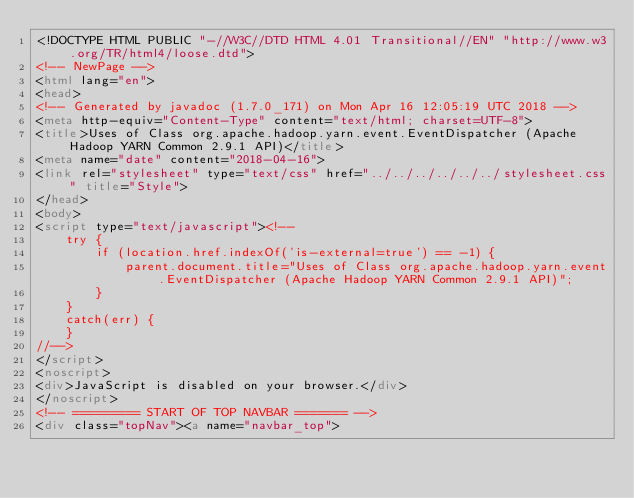Convert code to text. <code><loc_0><loc_0><loc_500><loc_500><_HTML_><!DOCTYPE HTML PUBLIC "-//W3C//DTD HTML 4.01 Transitional//EN" "http://www.w3.org/TR/html4/loose.dtd">
<!-- NewPage -->
<html lang="en">
<head>
<!-- Generated by javadoc (1.7.0_171) on Mon Apr 16 12:05:19 UTC 2018 -->
<meta http-equiv="Content-Type" content="text/html; charset=UTF-8">
<title>Uses of Class org.apache.hadoop.yarn.event.EventDispatcher (Apache Hadoop YARN Common 2.9.1 API)</title>
<meta name="date" content="2018-04-16">
<link rel="stylesheet" type="text/css" href="../../../../../../stylesheet.css" title="Style">
</head>
<body>
<script type="text/javascript"><!--
    try {
        if (location.href.indexOf('is-external=true') == -1) {
            parent.document.title="Uses of Class org.apache.hadoop.yarn.event.EventDispatcher (Apache Hadoop YARN Common 2.9.1 API)";
        }
    }
    catch(err) {
    }
//-->
</script>
<noscript>
<div>JavaScript is disabled on your browser.</div>
</noscript>
<!-- ========= START OF TOP NAVBAR ======= -->
<div class="topNav"><a name="navbar_top"></code> 